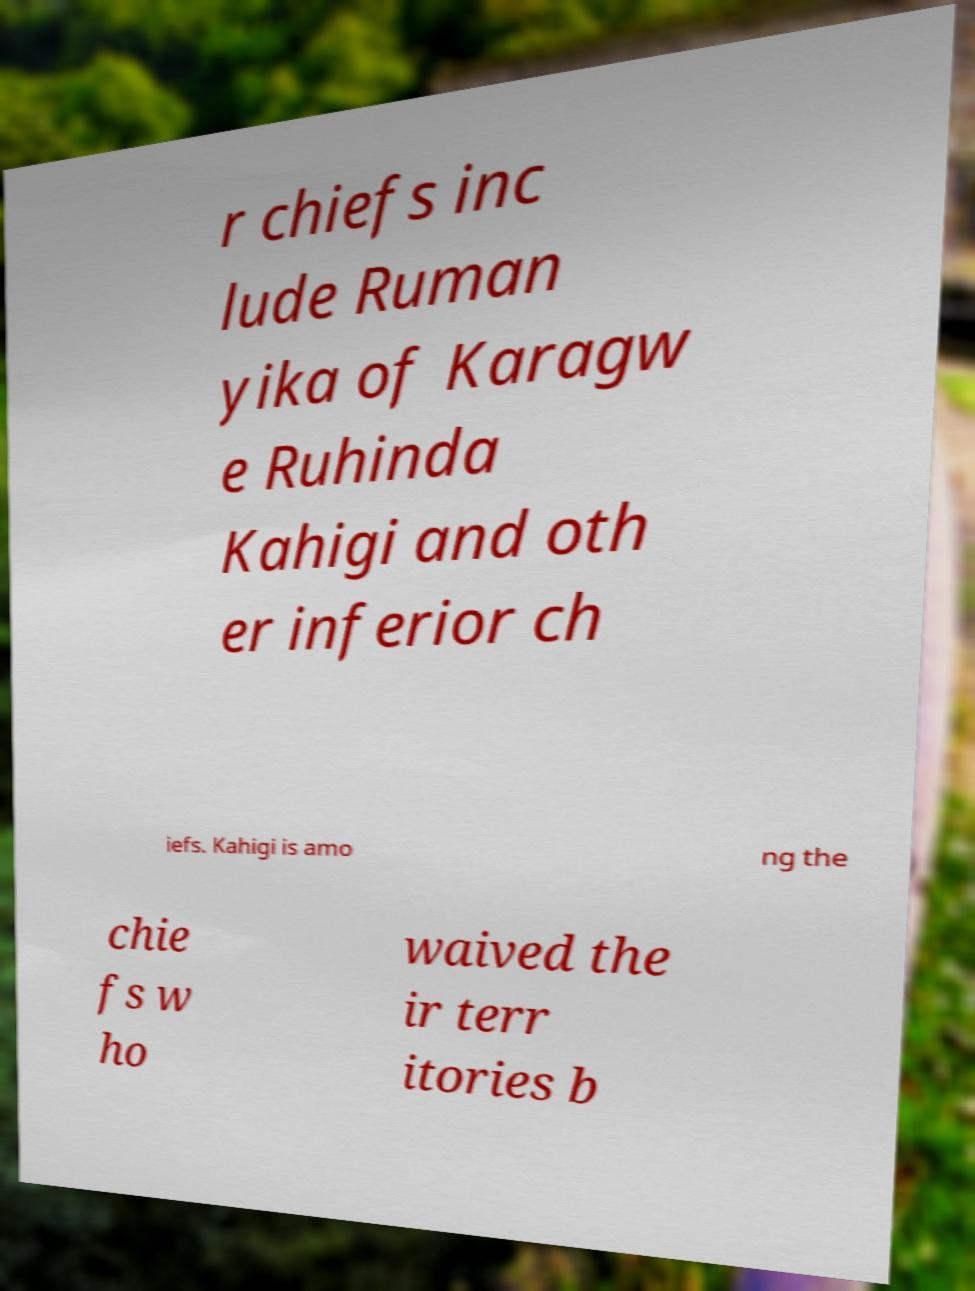Please identify and transcribe the text found in this image. r chiefs inc lude Ruman yika of Karagw e Ruhinda Kahigi and oth er inferior ch iefs. Kahigi is amo ng the chie fs w ho waived the ir terr itories b 